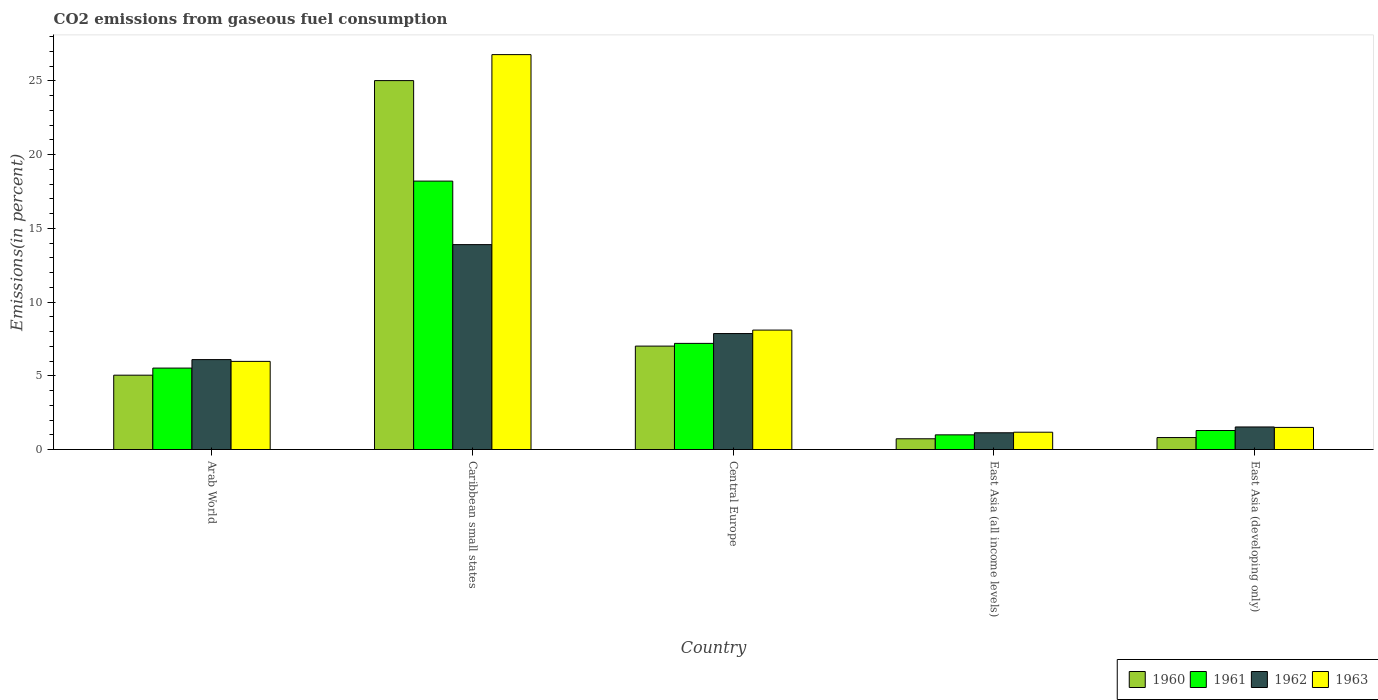How many groups of bars are there?
Provide a succinct answer. 5. How many bars are there on the 5th tick from the right?
Give a very brief answer. 4. What is the label of the 1st group of bars from the left?
Keep it short and to the point. Arab World. What is the total CO2 emitted in 1960 in East Asia (all income levels)?
Ensure brevity in your answer.  0.73. Across all countries, what is the maximum total CO2 emitted in 1963?
Your answer should be compact. 26.78. Across all countries, what is the minimum total CO2 emitted in 1961?
Provide a short and direct response. 0.99. In which country was the total CO2 emitted in 1963 maximum?
Provide a succinct answer. Caribbean small states. In which country was the total CO2 emitted in 1960 minimum?
Make the answer very short. East Asia (all income levels). What is the total total CO2 emitted in 1960 in the graph?
Make the answer very short. 38.61. What is the difference between the total CO2 emitted in 1961 in Caribbean small states and that in East Asia (developing only)?
Your response must be concise. 16.91. What is the difference between the total CO2 emitted in 1961 in Central Europe and the total CO2 emitted in 1962 in Caribbean small states?
Your answer should be very brief. -6.7. What is the average total CO2 emitted in 1961 per country?
Keep it short and to the point. 6.64. What is the difference between the total CO2 emitted of/in 1962 and total CO2 emitted of/in 1961 in Arab World?
Provide a short and direct response. 0.58. What is the ratio of the total CO2 emitted in 1963 in East Asia (all income levels) to that in East Asia (developing only)?
Your response must be concise. 0.78. Is the total CO2 emitted in 1963 in Arab World less than that in East Asia (developing only)?
Provide a short and direct response. No. Is the difference between the total CO2 emitted in 1962 in Caribbean small states and Central Europe greater than the difference between the total CO2 emitted in 1961 in Caribbean small states and Central Europe?
Offer a terse response. No. What is the difference between the highest and the second highest total CO2 emitted in 1963?
Give a very brief answer. -18.68. What is the difference between the highest and the lowest total CO2 emitted in 1962?
Keep it short and to the point. 12.76. What does the 2nd bar from the left in East Asia (all income levels) represents?
Your answer should be very brief. 1961. Is it the case that in every country, the sum of the total CO2 emitted in 1963 and total CO2 emitted in 1960 is greater than the total CO2 emitted in 1961?
Keep it short and to the point. Yes. Are all the bars in the graph horizontal?
Provide a short and direct response. No. What is the difference between two consecutive major ticks on the Y-axis?
Offer a very short reply. 5. Are the values on the major ticks of Y-axis written in scientific E-notation?
Offer a very short reply. No. Does the graph contain any zero values?
Give a very brief answer. No. Does the graph contain grids?
Your answer should be compact. No. How many legend labels are there?
Ensure brevity in your answer.  4. What is the title of the graph?
Offer a terse response. CO2 emissions from gaseous fuel consumption. What is the label or title of the X-axis?
Your answer should be very brief. Country. What is the label or title of the Y-axis?
Provide a short and direct response. Emissions(in percent). What is the Emissions(in percent) in 1960 in Arab World?
Your answer should be compact. 5.04. What is the Emissions(in percent) in 1961 in Arab World?
Give a very brief answer. 5.52. What is the Emissions(in percent) in 1962 in Arab World?
Your answer should be compact. 6.1. What is the Emissions(in percent) of 1963 in Arab World?
Ensure brevity in your answer.  5.98. What is the Emissions(in percent) in 1960 in Caribbean small states?
Make the answer very short. 25.02. What is the Emissions(in percent) in 1961 in Caribbean small states?
Provide a short and direct response. 18.2. What is the Emissions(in percent) of 1962 in Caribbean small states?
Your response must be concise. 13.89. What is the Emissions(in percent) of 1963 in Caribbean small states?
Make the answer very short. 26.78. What is the Emissions(in percent) in 1960 in Central Europe?
Keep it short and to the point. 7.01. What is the Emissions(in percent) of 1961 in Central Europe?
Your answer should be compact. 7.2. What is the Emissions(in percent) of 1962 in Central Europe?
Your answer should be compact. 7.86. What is the Emissions(in percent) of 1963 in Central Europe?
Give a very brief answer. 8.1. What is the Emissions(in percent) of 1960 in East Asia (all income levels)?
Your response must be concise. 0.73. What is the Emissions(in percent) of 1961 in East Asia (all income levels)?
Keep it short and to the point. 0.99. What is the Emissions(in percent) of 1962 in East Asia (all income levels)?
Your answer should be very brief. 1.14. What is the Emissions(in percent) of 1963 in East Asia (all income levels)?
Make the answer very short. 1.17. What is the Emissions(in percent) in 1960 in East Asia (developing only)?
Your response must be concise. 0.81. What is the Emissions(in percent) in 1961 in East Asia (developing only)?
Give a very brief answer. 1.29. What is the Emissions(in percent) of 1962 in East Asia (developing only)?
Provide a succinct answer. 1.53. What is the Emissions(in percent) of 1963 in East Asia (developing only)?
Make the answer very short. 1.5. Across all countries, what is the maximum Emissions(in percent) in 1960?
Give a very brief answer. 25.02. Across all countries, what is the maximum Emissions(in percent) in 1961?
Provide a short and direct response. 18.2. Across all countries, what is the maximum Emissions(in percent) in 1962?
Make the answer very short. 13.89. Across all countries, what is the maximum Emissions(in percent) in 1963?
Your answer should be compact. 26.78. Across all countries, what is the minimum Emissions(in percent) of 1960?
Offer a very short reply. 0.73. Across all countries, what is the minimum Emissions(in percent) of 1961?
Your response must be concise. 0.99. Across all countries, what is the minimum Emissions(in percent) of 1962?
Offer a very short reply. 1.14. Across all countries, what is the minimum Emissions(in percent) in 1963?
Provide a short and direct response. 1.17. What is the total Emissions(in percent) of 1960 in the graph?
Ensure brevity in your answer.  38.61. What is the total Emissions(in percent) in 1961 in the graph?
Provide a short and direct response. 33.2. What is the total Emissions(in percent) in 1962 in the graph?
Keep it short and to the point. 30.52. What is the total Emissions(in percent) of 1963 in the graph?
Offer a very short reply. 43.53. What is the difference between the Emissions(in percent) in 1960 in Arab World and that in Caribbean small states?
Provide a succinct answer. -19.97. What is the difference between the Emissions(in percent) in 1961 in Arab World and that in Caribbean small states?
Provide a short and direct response. -12.68. What is the difference between the Emissions(in percent) in 1962 in Arab World and that in Caribbean small states?
Give a very brief answer. -7.8. What is the difference between the Emissions(in percent) of 1963 in Arab World and that in Caribbean small states?
Provide a short and direct response. -20.8. What is the difference between the Emissions(in percent) of 1960 in Arab World and that in Central Europe?
Your response must be concise. -1.97. What is the difference between the Emissions(in percent) of 1961 in Arab World and that in Central Europe?
Give a very brief answer. -1.68. What is the difference between the Emissions(in percent) in 1962 in Arab World and that in Central Europe?
Your answer should be compact. -1.77. What is the difference between the Emissions(in percent) of 1963 in Arab World and that in Central Europe?
Offer a terse response. -2.12. What is the difference between the Emissions(in percent) in 1960 in Arab World and that in East Asia (all income levels)?
Provide a short and direct response. 4.31. What is the difference between the Emissions(in percent) of 1961 in Arab World and that in East Asia (all income levels)?
Offer a terse response. 4.53. What is the difference between the Emissions(in percent) in 1962 in Arab World and that in East Asia (all income levels)?
Provide a short and direct response. 4.96. What is the difference between the Emissions(in percent) in 1963 in Arab World and that in East Asia (all income levels)?
Keep it short and to the point. 4.8. What is the difference between the Emissions(in percent) in 1960 in Arab World and that in East Asia (developing only)?
Give a very brief answer. 4.23. What is the difference between the Emissions(in percent) of 1961 in Arab World and that in East Asia (developing only)?
Your response must be concise. 4.23. What is the difference between the Emissions(in percent) of 1962 in Arab World and that in East Asia (developing only)?
Provide a short and direct response. 4.57. What is the difference between the Emissions(in percent) of 1963 in Arab World and that in East Asia (developing only)?
Provide a short and direct response. 4.48. What is the difference between the Emissions(in percent) of 1960 in Caribbean small states and that in Central Europe?
Give a very brief answer. 18. What is the difference between the Emissions(in percent) in 1961 in Caribbean small states and that in Central Europe?
Provide a short and direct response. 11. What is the difference between the Emissions(in percent) of 1962 in Caribbean small states and that in Central Europe?
Provide a short and direct response. 6.03. What is the difference between the Emissions(in percent) of 1963 in Caribbean small states and that in Central Europe?
Keep it short and to the point. 18.68. What is the difference between the Emissions(in percent) in 1960 in Caribbean small states and that in East Asia (all income levels)?
Give a very brief answer. 24.29. What is the difference between the Emissions(in percent) of 1961 in Caribbean small states and that in East Asia (all income levels)?
Provide a short and direct response. 17.21. What is the difference between the Emissions(in percent) of 1962 in Caribbean small states and that in East Asia (all income levels)?
Your answer should be compact. 12.76. What is the difference between the Emissions(in percent) in 1963 in Caribbean small states and that in East Asia (all income levels)?
Your response must be concise. 25.6. What is the difference between the Emissions(in percent) in 1960 in Caribbean small states and that in East Asia (developing only)?
Your response must be concise. 24.2. What is the difference between the Emissions(in percent) in 1961 in Caribbean small states and that in East Asia (developing only)?
Your answer should be very brief. 16.91. What is the difference between the Emissions(in percent) of 1962 in Caribbean small states and that in East Asia (developing only)?
Give a very brief answer. 12.36. What is the difference between the Emissions(in percent) of 1963 in Caribbean small states and that in East Asia (developing only)?
Offer a terse response. 25.28. What is the difference between the Emissions(in percent) of 1960 in Central Europe and that in East Asia (all income levels)?
Your response must be concise. 6.28. What is the difference between the Emissions(in percent) in 1961 in Central Europe and that in East Asia (all income levels)?
Offer a very short reply. 6.2. What is the difference between the Emissions(in percent) of 1962 in Central Europe and that in East Asia (all income levels)?
Keep it short and to the point. 6.73. What is the difference between the Emissions(in percent) of 1963 in Central Europe and that in East Asia (all income levels)?
Ensure brevity in your answer.  6.92. What is the difference between the Emissions(in percent) in 1960 in Central Europe and that in East Asia (developing only)?
Make the answer very short. 6.2. What is the difference between the Emissions(in percent) of 1961 in Central Europe and that in East Asia (developing only)?
Your answer should be compact. 5.91. What is the difference between the Emissions(in percent) in 1962 in Central Europe and that in East Asia (developing only)?
Provide a short and direct response. 6.33. What is the difference between the Emissions(in percent) of 1963 in Central Europe and that in East Asia (developing only)?
Give a very brief answer. 6.6. What is the difference between the Emissions(in percent) in 1960 in East Asia (all income levels) and that in East Asia (developing only)?
Offer a very short reply. -0.08. What is the difference between the Emissions(in percent) of 1961 in East Asia (all income levels) and that in East Asia (developing only)?
Offer a terse response. -0.29. What is the difference between the Emissions(in percent) of 1962 in East Asia (all income levels) and that in East Asia (developing only)?
Ensure brevity in your answer.  -0.39. What is the difference between the Emissions(in percent) of 1963 in East Asia (all income levels) and that in East Asia (developing only)?
Make the answer very short. -0.33. What is the difference between the Emissions(in percent) of 1960 in Arab World and the Emissions(in percent) of 1961 in Caribbean small states?
Ensure brevity in your answer.  -13.16. What is the difference between the Emissions(in percent) of 1960 in Arab World and the Emissions(in percent) of 1962 in Caribbean small states?
Offer a terse response. -8.85. What is the difference between the Emissions(in percent) of 1960 in Arab World and the Emissions(in percent) of 1963 in Caribbean small states?
Provide a succinct answer. -21.74. What is the difference between the Emissions(in percent) in 1961 in Arab World and the Emissions(in percent) in 1962 in Caribbean small states?
Your answer should be very brief. -8.37. What is the difference between the Emissions(in percent) of 1961 in Arab World and the Emissions(in percent) of 1963 in Caribbean small states?
Give a very brief answer. -21.26. What is the difference between the Emissions(in percent) of 1962 in Arab World and the Emissions(in percent) of 1963 in Caribbean small states?
Provide a succinct answer. -20.68. What is the difference between the Emissions(in percent) of 1960 in Arab World and the Emissions(in percent) of 1961 in Central Europe?
Ensure brevity in your answer.  -2.16. What is the difference between the Emissions(in percent) in 1960 in Arab World and the Emissions(in percent) in 1962 in Central Europe?
Offer a terse response. -2.82. What is the difference between the Emissions(in percent) of 1960 in Arab World and the Emissions(in percent) of 1963 in Central Europe?
Offer a very short reply. -3.06. What is the difference between the Emissions(in percent) in 1961 in Arab World and the Emissions(in percent) in 1962 in Central Europe?
Provide a short and direct response. -2.34. What is the difference between the Emissions(in percent) of 1961 in Arab World and the Emissions(in percent) of 1963 in Central Europe?
Your response must be concise. -2.58. What is the difference between the Emissions(in percent) of 1962 in Arab World and the Emissions(in percent) of 1963 in Central Europe?
Make the answer very short. -2. What is the difference between the Emissions(in percent) of 1960 in Arab World and the Emissions(in percent) of 1961 in East Asia (all income levels)?
Provide a short and direct response. 4.05. What is the difference between the Emissions(in percent) in 1960 in Arab World and the Emissions(in percent) in 1962 in East Asia (all income levels)?
Your answer should be very brief. 3.91. What is the difference between the Emissions(in percent) in 1960 in Arab World and the Emissions(in percent) in 1963 in East Asia (all income levels)?
Keep it short and to the point. 3.87. What is the difference between the Emissions(in percent) in 1961 in Arab World and the Emissions(in percent) in 1962 in East Asia (all income levels)?
Offer a very short reply. 4.39. What is the difference between the Emissions(in percent) in 1961 in Arab World and the Emissions(in percent) in 1963 in East Asia (all income levels)?
Your answer should be compact. 4.35. What is the difference between the Emissions(in percent) in 1962 in Arab World and the Emissions(in percent) in 1963 in East Asia (all income levels)?
Offer a very short reply. 4.92. What is the difference between the Emissions(in percent) of 1960 in Arab World and the Emissions(in percent) of 1961 in East Asia (developing only)?
Give a very brief answer. 3.75. What is the difference between the Emissions(in percent) in 1960 in Arab World and the Emissions(in percent) in 1962 in East Asia (developing only)?
Provide a succinct answer. 3.51. What is the difference between the Emissions(in percent) of 1960 in Arab World and the Emissions(in percent) of 1963 in East Asia (developing only)?
Offer a terse response. 3.54. What is the difference between the Emissions(in percent) of 1961 in Arab World and the Emissions(in percent) of 1962 in East Asia (developing only)?
Your response must be concise. 3.99. What is the difference between the Emissions(in percent) of 1961 in Arab World and the Emissions(in percent) of 1963 in East Asia (developing only)?
Offer a terse response. 4.02. What is the difference between the Emissions(in percent) in 1962 in Arab World and the Emissions(in percent) in 1963 in East Asia (developing only)?
Give a very brief answer. 4.6. What is the difference between the Emissions(in percent) in 1960 in Caribbean small states and the Emissions(in percent) in 1961 in Central Europe?
Offer a very short reply. 17.82. What is the difference between the Emissions(in percent) in 1960 in Caribbean small states and the Emissions(in percent) in 1962 in Central Europe?
Provide a succinct answer. 17.15. What is the difference between the Emissions(in percent) of 1960 in Caribbean small states and the Emissions(in percent) of 1963 in Central Europe?
Your answer should be very brief. 16.92. What is the difference between the Emissions(in percent) of 1961 in Caribbean small states and the Emissions(in percent) of 1962 in Central Europe?
Your answer should be compact. 10.34. What is the difference between the Emissions(in percent) in 1961 in Caribbean small states and the Emissions(in percent) in 1963 in Central Europe?
Your response must be concise. 10.1. What is the difference between the Emissions(in percent) of 1962 in Caribbean small states and the Emissions(in percent) of 1963 in Central Europe?
Make the answer very short. 5.8. What is the difference between the Emissions(in percent) of 1960 in Caribbean small states and the Emissions(in percent) of 1961 in East Asia (all income levels)?
Provide a succinct answer. 24.02. What is the difference between the Emissions(in percent) in 1960 in Caribbean small states and the Emissions(in percent) in 1962 in East Asia (all income levels)?
Your answer should be very brief. 23.88. What is the difference between the Emissions(in percent) in 1960 in Caribbean small states and the Emissions(in percent) in 1963 in East Asia (all income levels)?
Provide a short and direct response. 23.84. What is the difference between the Emissions(in percent) of 1961 in Caribbean small states and the Emissions(in percent) of 1962 in East Asia (all income levels)?
Give a very brief answer. 17.07. What is the difference between the Emissions(in percent) in 1961 in Caribbean small states and the Emissions(in percent) in 1963 in East Asia (all income levels)?
Make the answer very short. 17.03. What is the difference between the Emissions(in percent) of 1962 in Caribbean small states and the Emissions(in percent) of 1963 in East Asia (all income levels)?
Keep it short and to the point. 12.72. What is the difference between the Emissions(in percent) of 1960 in Caribbean small states and the Emissions(in percent) of 1961 in East Asia (developing only)?
Keep it short and to the point. 23.73. What is the difference between the Emissions(in percent) in 1960 in Caribbean small states and the Emissions(in percent) in 1962 in East Asia (developing only)?
Your answer should be compact. 23.49. What is the difference between the Emissions(in percent) of 1960 in Caribbean small states and the Emissions(in percent) of 1963 in East Asia (developing only)?
Provide a succinct answer. 23.52. What is the difference between the Emissions(in percent) in 1961 in Caribbean small states and the Emissions(in percent) in 1962 in East Asia (developing only)?
Provide a short and direct response. 16.67. What is the difference between the Emissions(in percent) in 1961 in Caribbean small states and the Emissions(in percent) in 1963 in East Asia (developing only)?
Offer a very short reply. 16.7. What is the difference between the Emissions(in percent) in 1962 in Caribbean small states and the Emissions(in percent) in 1963 in East Asia (developing only)?
Keep it short and to the point. 12.39. What is the difference between the Emissions(in percent) in 1960 in Central Europe and the Emissions(in percent) in 1961 in East Asia (all income levels)?
Your answer should be very brief. 6.02. What is the difference between the Emissions(in percent) in 1960 in Central Europe and the Emissions(in percent) in 1962 in East Asia (all income levels)?
Ensure brevity in your answer.  5.88. What is the difference between the Emissions(in percent) in 1960 in Central Europe and the Emissions(in percent) in 1963 in East Asia (all income levels)?
Offer a terse response. 5.84. What is the difference between the Emissions(in percent) in 1961 in Central Europe and the Emissions(in percent) in 1962 in East Asia (all income levels)?
Make the answer very short. 6.06. What is the difference between the Emissions(in percent) in 1961 in Central Europe and the Emissions(in percent) in 1963 in East Asia (all income levels)?
Your response must be concise. 6.02. What is the difference between the Emissions(in percent) of 1962 in Central Europe and the Emissions(in percent) of 1963 in East Asia (all income levels)?
Provide a succinct answer. 6.69. What is the difference between the Emissions(in percent) in 1960 in Central Europe and the Emissions(in percent) in 1961 in East Asia (developing only)?
Your answer should be compact. 5.72. What is the difference between the Emissions(in percent) in 1960 in Central Europe and the Emissions(in percent) in 1962 in East Asia (developing only)?
Your response must be concise. 5.48. What is the difference between the Emissions(in percent) of 1960 in Central Europe and the Emissions(in percent) of 1963 in East Asia (developing only)?
Provide a succinct answer. 5.51. What is the difference between the Emissions(in percent) of 1961 in Central Europe and the Emissions(in percent) of 1962 in East Asia (developing only)?
Give a very brief answer. 5.67. What is the difference between the Emissions(in percent) in 1961 in Central Europe and the Emissions(in percent) in 1963 in East Asia (developing only)?
Give a very brief answer. 5.7. What is the difference between the Emissions(in percent) in 1962 in Central Europe and the Emissions(in percent) in 1963 in East Asia (developing only)?
Ensure brevity in your answer.  6.36. What is the difference between the Emissions(in percent) of 1960 in East Asia (all income levels) and the Emissions(in percent) of 1961 in East Asia (developing only)?
Your answer should be very brief. -0.56. What is the difference between the Emissions(in percent) of 1960 in East Asia (all income levels) and the Emissions(in percent) of 1962 in East Asia (developing only)?
Provide a succinct answer. -0.8. What is the difference between the Emissions(in percent) of 1960 in East Asia (all income levels) and the Emissions(in percent) of 1963 in East Asia (developing only)?
Your answer should be very brief. -0.77. What is the difference between the Emissions(in percent) in 1961 in East Asia (all income levels) and the Emissions(in percent) in 1962 in East Asia (developing only)?
Provide a succinct answer. -0.54. What is the difference between the Emissions(in percent) of 1961 in East Asia (all income levels) and the Emissions(in percent) of 1963 in East Asia (developing only)?
Offer a very short reply. -0.51. What is the difference between the Emissions(in percent) in 1962 in East Asia (all income levels) and the Emissions(in percent) in 1963 in East Asia (developing only)?
Make the answer very short. -0.36. What is the average Emissions(in percent) of 1960 per country?
Offer a very short reply. 7.72. What is the average Emissions(in percent) of 1961 per country?
Make the answer very short. 6.64. What is the average Emissions(in percent) in 1962 per country?
Your response must be concise. 6.1. What is the average Emissions(in percent) of 1963 per country?
Provide a short and direct response. 8.71. What is the difference between the Emissions(in percent) in 1960 and Emissions(in percent) in 1961 in Arab World?
Provide a short and direct response. -0.48. What is the difference between the Emissions(in percent) of 1960 and Emissions(in percent) of 1962 in Arab World?
Keep it short and to the point. -1.06. What is the difference between the Emissions(in percent) in 1960 and Emissions(in percent) in 1963 in Arab World?
Your response must be concise. -0.94. What is the difference between the Emissions(in percent) of 1961 and Emissions(in percent) of 1962 in Arab World?
Provide a succinct answer. -0.58. What is the difference between the Emissions(in percent) in 1961 and Emissions(in percent) in 1963 in Arab World?
Your response must be concise. -0.45. What is the difference between the Emissions(in percent) in 1962 and Emissions(in percent) in 1963 in Arab World?
Offer a very short reply. 0.12. What is the difference between the Emissions(in percent) in 1960 and Emissions(in percent) in 1961 in Caribbean small states?
Your answer should be compact. 6.81. What is the difference between the Emissions(in percent) in 1960 and Emissions(in percent) in 1962 in Caribbean small states?
Your answer should be compact. 11.12. What is the difference between the Emissions(in percent) of 1960 and Emissions(in percent) of 1963 in Caribbean small states?
Your response must be concise. -1.76. What is the difference between the Emissions(in percent) of 1961 and Emissions(in percent) of 1962 in Caribbean small states?
Keep it short and to the point. 4.31. What is the difference between the Emissions(in percent) in 1961 and Emissions(in percent) in 1963 in Caribbean small states?
Offer a terse response. -8.58. What is the difference between the Emissions(in percent) of 1962 and Emissions(in percent) of 1963 in Caribbean small states?
Give a very brief answer. -12.88. What is the difference between the Emissions(in percent) in 1960 and Emissions(in percent) in 1961 in Central Europe?
Ensure brevity in your answer.  -0.19. What is the difference between the Emissions(in percent) in 1960 and Emissions(in percent) in 1962 in Central Europe?
Your answer should be compact. -0.85. What is the difference between the Emissions(in percent) of 1960 and Emissions(in percent) of 1963 in Central Europe?
Your answer should be compact. -1.09. What is the difference between the Emissions(in percent) of 1961 and Emissions(in percent) of 1962 in Central Europe?
Your answer should be very brief. -0.67. What is the difference between the Emissions(in percent) in 1961 and Emissions(in percent) in 1963 in Central Europe?
Your answer should be compact. -0.9. What is the difference between the Emissions(in percent) in 1962 and Emissions(in percent) in 1963 in Central Europe?
Your answer should be very brief. -0.24. What is the difference between the Emissions(in percent) of 1960 and Emissions(in percent) of 1961 in East Asia (all income levels)?
Give a very brief answer. -0.27. What is the difference between the Emissions(in percent) in 1960 and Emissions(in percent) in 1962 in East Asia (all income levels)?
Ensure brevity in your answer.  -0.41. What is the difference between the Emissions(in percent) of 1960 and Emissions(in percent) of 1963 in East Asia (all income levels)?
Ensure brevity in your answer.  -0.45. What is the difference between the Emissions(in percent) in 1961 and Emissions(in percent) in 1962 in East Asia (all income levels)?
Your answer should be very brief. -0.14. What is the difference between the Emissions(in percent) in 1961 and Emissions(in percent) in 1963 in East Asia (all income levels)?
Make the answer very short. -0.18. What is the difference between the Emissions(in percent) of 1962 and Emissions(in percent) of 1963 in East Asia (all income levels)?
Make the answer very short. -0.04. What is the difference between the Emissions(in percent) of 1960 and Emissions(in percent) of 1961 in East Asia (developing only)?
Provide a short and direct response. -0.48. What is the difference between the Emissions(in percent) in 1960 and Emissions(in percent) in 1962 in East Asia (developing only)?
Offer a very short reply. -0.72. What is the difference between the Emissions(in percent) in 1960 and Emissions(in percent) in 1963 in East Asia (developing only)?
Make the answer very short. -0.69. What is the difference between the Emissions(in percent) in 1961 and Emissions(in percent) in 1962 in East Asia (developing only)?
Provide a short and direct response. -0.24. What is the difference between the Emissions(in percent) of 1961 and Emissions(in percent) of 1963 in East Asia (developing only)?
Give a very brief answer. -0.21. What is the difference between the Emissions(in percent) of 1962 and Emissions(in percent) of 1963 in East Asia (developing only)?
Offer a very short reply. 0.03. What is the ratio of the Emissions(in percent) of 1960 in Arab World to that in Caribbean small states?
Your answer should be very brief. 0.2. What is the ratio of the Emissions(in percent) in 1961 in Arab World to that in Caribbean small states?
Ensure brevity in your answer.  0.3. What is the ratio of the Emissions(in percent) of 1962 in Arab World to that in Caribbean small states?
Offer a terse response. 0.44. What is the ratio of the Emissions(in percent) of 1963 in Arab World to that in Caribbean small states?
Provide a succinct answer. 0.22. What is the ratio of the Emissions(in percent) in 1960 in Arab World to that in Central Europe?
Provide a succinct answer. 0.72. What is the ratio of the Emissions(in percent) in 1961 in Arab World to that in Central Europe?
Your answer should be compact. 0.77. What is the ratio of the Emissions(in percent) of 1962 in Arab World to that in Central Europe?
Ensure brevity in your answer.  0.78. What is the ratio of the Emissions(in percent) of 1963 in Arab World to that in Central Europe?
Offer a terse response. 0.74. What is the ratio of the Emissions(in percent) in 1960 in Arab World to that in East Asia (all income levels)?
Your answer should be compact. 6.92. What is the ratio of the Emissions(in percent) in 1961 in Arab World to that in East Asia (all income levels)?
Provide a short and direct response. 5.55. What is the ratio of the Emissions(in percent) in 1962 in Arab World to that in East Asia (all income levels)?
Keep it short and to the point. 5.37. What is the ratio of the Emissions(in percent) in 1963 in Arab World to that in East Asia (all income levels)?
Make the answer very short. 5.09. What is the ratio of the Emissions(in percent) of 1960 in Arab World to that in East Asia (developing only)?
Make the answer very short. 6.21. What is the ratio of the Emissions(in percent) in 1961 in Arab World to that in East Asia (developing only)?
Keep it short and to the point. 4.28. What is the ratio of the Emissions(in percent) in 1962 in Arab World to that in East Asia (developing only)?
Make the answer very short. 3.99. What is the ratio of the Emissions(in percent) of 1963 in Arab World to that in East Asia (developing only)?
Give a very brief answer. 3.99. What is the ratio of the Emissions(in percent) in 1960 in Caribbean small states to that in Central Europe?
Your response must be concise. 3.57. What is the ratio of the Emissions(in percent) of 1961 in Caribbean small states to that in Central Europe?
Provide a succinct answer. 2.53. What is the ratio of the Emissions(in percent) of 1962 in Caribbean small states to that in Central Europe?
Ensure brevity in your answer.  1.77. What is the ratio of the Emissions(in percent) of 1963 in Caribbean small states to that in Central Europe?
Your answer should be very brief. 3.31. What is the ratio of the Emissions(in percent) in 1960 in Caribbean small states to that in East Asia (all income levels)?
Offer a very short reply. 34.34. What is the ratio of the Emissions(in percent) in 1961 in Caribbean small states to that in East Asia (all income levels)?
Make the answer very short. 18.31. What is the ratio of the Emissions(in percent) of 1962 in Caribbean small states to that in East Asia (all income levels)?
Your answer should be compact. 12.24. What is the ratio of the Emissions(in percent) of 1963 in Caribbean small states to that in East Asia (all income levels)?
Offer a very short reply. 22.81. What is the ratio of the Emissions(in percent) of 1960 in Caribbean small states to that in East Asia (developing only)?
Keep it short and to the point. 30.82. What is the ratio of the Emissions(in percent) of 1961 in Caribbean small states to that in East Asia (developing only)?
Keep it short and to the point. 14.12. What is the ratio of the Emissions(in percent) of 1962 in Caribbean small states to that in East Asia (developing only)?
Keep it short and to the point. 9.09. What is the ratio of the Emissions(in percent) of 1963 in Caribbean small states to that in East Asia (developing only)?
Give a very brief answer. 17.86. What is the ratio of the Emissions(in percent) of 1960 in Central Europe to that in East Asia (all income levels)?
Provide a short and direct response. 9.63. What is the ratio of the Emissions(in percent) in 1961 in Central Europe to that in East Asia (all income levels)?
Your response must be concise. 7.24. What is the ratio of the Emissions(in percent) in 1962 in Central Europe to that in East Asia (all income levels)?
Your answer should be very brief. 6.93. What is the ratio of the Emissions(in percent) of 1963 in Central Europe to that in East Asia (all income levels)?
Ensure brevity in your answer.  6.9. What is the ratio of the Emissions(in percent) of 1960 in Central Europe to that in East Asia (developing only)?
Your answer should be very brief. 8.64. What is the ratio of the Emissions(in percent) in 1961 in Central Europe to that in East Asia (developing only)?
Keep it short and to the point. 5.58. What is the ratio of the Emissions(in percent) in 1962 in Central Europe to that in East Asia (developing only)?
Offer a very short reply. 5.14. What is the ratio of the Emissions(in percent) of 1963 in Central Europe to that in East Asia (developing only)?
Provide a succinct answer. 5.4. What is the ratio of the Emissions(in percent) in 1960 in East Asia (all income levels) to that in East Asia (developing only)?
Your answer should be very brief. 0.9. What is the ratio of the Emissions(in percent) of 1961 in East Asia (all income levels) to that in East Asia (developing only)?
Keep it short and to the point. 0.77. What is the ratio of the Emissions(in percent) in 1962 in East Asia (all income levels) to that in East Asia (developing only)?
Your response must be concise. 0.74. What is the ratio of the Emissions(in percent) in 1963 in East Asia (all income levels) to that in East Asia (developing only)?
Offer a terse response. 0.78. What is the difference between the highest and the second highest Emissions(in percent) in 1960?
Offer a terse response. 18. What is the difference between the highest and the second highest Emissions(in percent) of 1961?
Provide a succinct answer. 11. What is the difference between the highest and the second highest Emissions(in percent) of 1962?
Keep it short and to the point. 6.03. What is the difference between the highest and the second highest Emissions(in percent) in 1963?
Ensure brevity in your answer.  18.68. What is the difference between the highest and the lowest Emissions(in percent) of 1960?
Make the answer very short. 24.29. What is the difference between the highest and the lowest Emissions(in percent) in 1961?
Offer a very short reply. 17.21. What is the difference between the highest and the lowest Emissions(in percent) of 1962?
Provide a short and direct response. 12.76. What is the difference between the highest and the lowest Emissions(in percent) in 1963?
Your response must be concise. 25.6. 